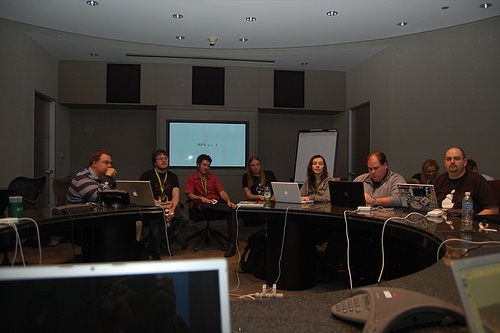Describe the objects in this image and their specific colors. I can see tv in gray, black, lightgray, and darkgray tones, laptop in gray, black, lightgray, and darkgray tones, tv in gray, darkgray, black, and lightblue tones, laptop in gray, olive, and black tones, and people in gray, black, maroon, and brown tones in this image. 